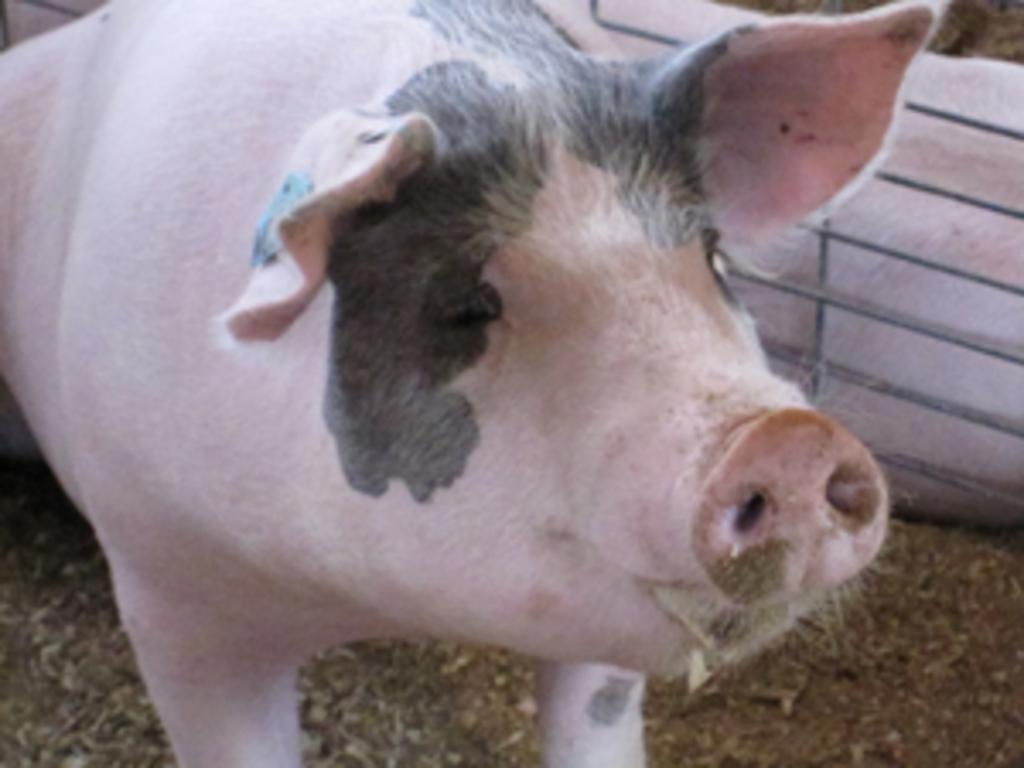What type of animal is in the image? There is a pig in the image. What is at the bottom of the image? There is soil at the bottom of the image. Can you describe the other animal in the image? There is another animal on the right side of the image. What type of furniture can be seen in the image? There is no furniture present in the image. Can you describe the rabbit in the image? There is no rabbit present in the image; only a pig and another unspecified animal are mentioned. 